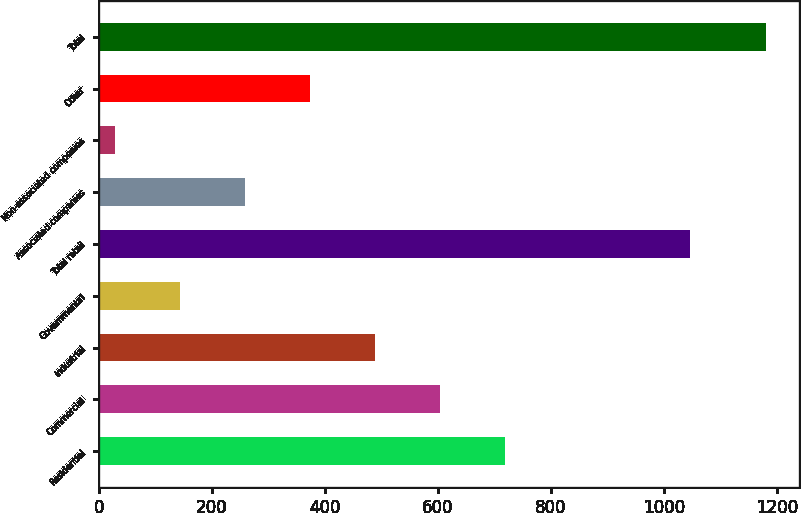Convert chart. <chart><loc_0><loc_0><loc_500><loc_500><bar_chart><fcel>Residential<fcel>Commercial<fcel>Industrial<fcel>Governmental<fcel>Total retail<fcel>Associated companies<fcel>Non-associated companies<fcel>Other<fcel>Total<nl><fcel>719.2<fcel>604<fcel>488.8<fcel>143.2<fcel>1046<fcel>258.4<fcel>28<fcel>373.6<fcel>1180<nl></chart> 